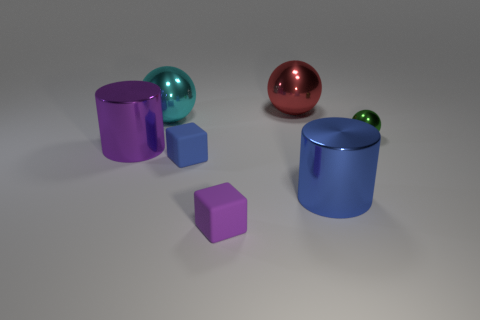There is a large shiny cylinder left of the tiny purple cube; is it the same color as the small rubber object left of the purple rubber cube?
Provide a short and direct response. No. What is the shape of the thing that is both to the left of the blue shiny object and in front of the tiny blue rubber cube?
Keep it short and to the point. Cube. There is a sphere that is the same size as the blue cube; what color is it?
Provide a succinct answer. Green. Is there a cube that has the same color as the small sphere?
Your response must be concise. No. Do the rubber thing that is behind the purple matte thing and the cylinder on the right side of the large purple object have the same size?
Your answer should be compact. No. What is the material of the large object that is on the right side of the cyan metal object and in front of the large cyan sphere?
Offer a terse response. Metal. What number of other objects are there of the same size as the purple cube?
Provide a short and direct response. 2. There is a purple thing in front of the large purple thing; what is it made of?
Offer a terse response. Rubber. Does the big blue metal object have the same shape as the blue matte thing?
Provide a succinct answer. No. What number of other things are the same shape as the tiny green metal object?
Offer a very short reply. 2. 